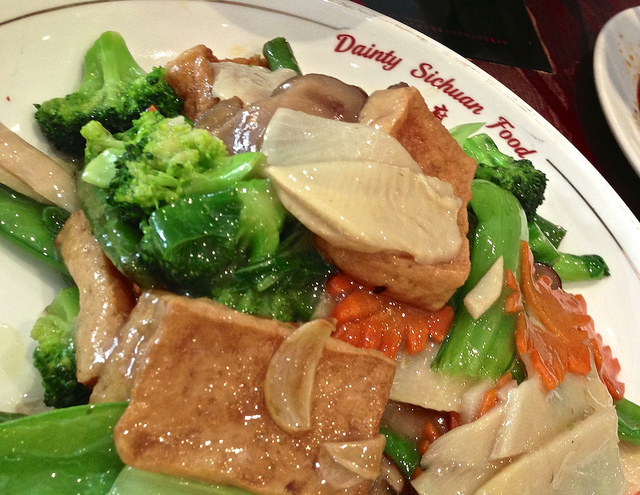Read and extract the text from this image. Dainty Sichuan Food 